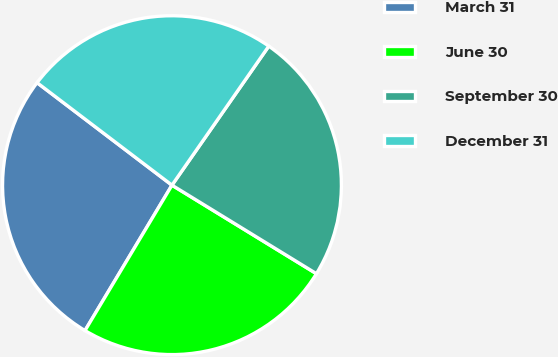Convert chart. <chart><loc_0><loc_0><loc_500><loc_500><pie_chart><fcel>March 31<fcel>June 30<fcel>September 30<fcel>December 31<nl><fcel>26.76%<fcel>24.83%<fcel>24.07%<fcel>24.34%<nl></chart> 